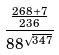<formula> <loc_0><loc_0><loc_500><loc_500>\frac { \frac { 2 6 8 + 7 } { 2 3 6 } } { 8 8 ^ { \sqrt { 3 4 7 } } }</formula> 